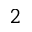<formula> <loc_0><loc_0><loc_500><loc_500>_ { 2 }</formula> 